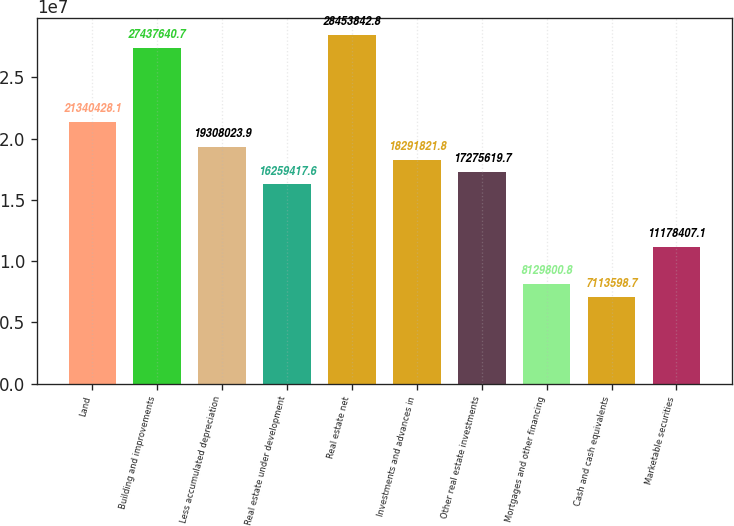Convert chart. <chart><loc_0><loc_0><loc_500><loc_500><bar_chart><fcel>Land<fcel>Building and improvements<fcel>Less accumulated depreciation<fcel>Real estate under development<fcel>Real estate net<fcel>Investments and advances in<fcel>Other real estate investments<fcel>Mortgages and other financing<fcel>Cash and cash equivalents<fcel>Marketable securities<nl><fcel>2.13404e+07<fcel>2.74376e+07<fcel>1.9308e+07<fcel>1.62594e+07<fcel>2.84538e+07<fcel>1.82918e+07<fcel>1.72756e+07<fcel>8.1298e+06<fcel>7.1136e+06<fcel>1.11784e+07<nl></chart> 